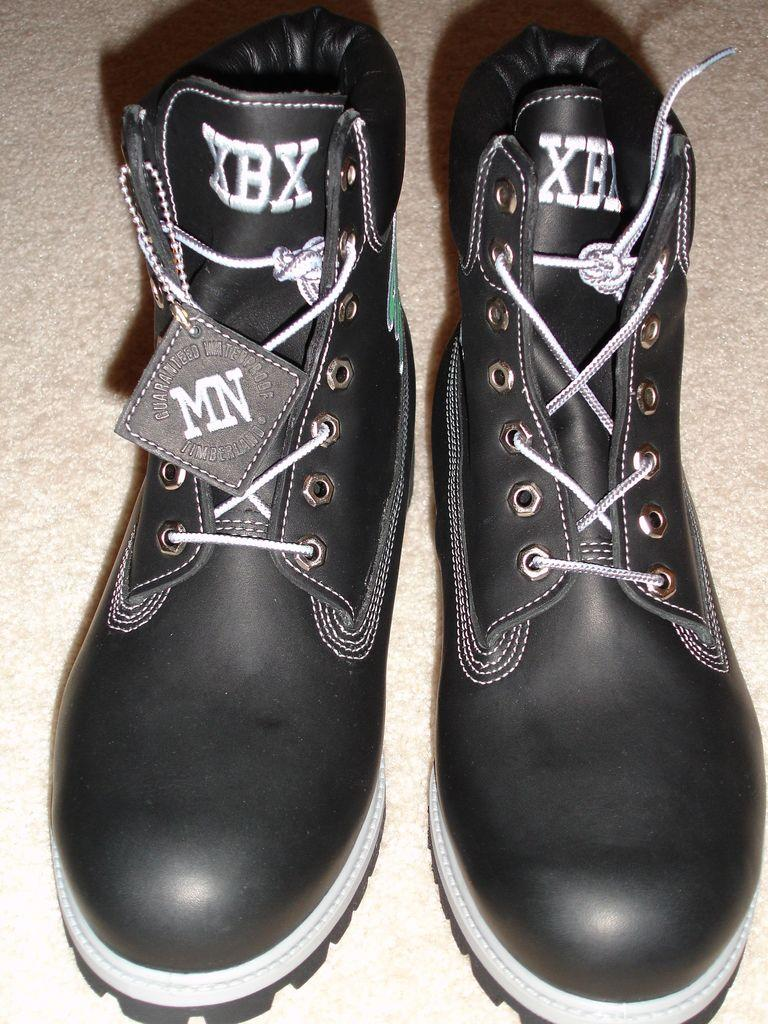What is on the floor in the image? There are shoes on the floor in the image. How does the sponge expand when placed in water in the image? There is no sponge present in the image, and therefore no expansion can be observed. 